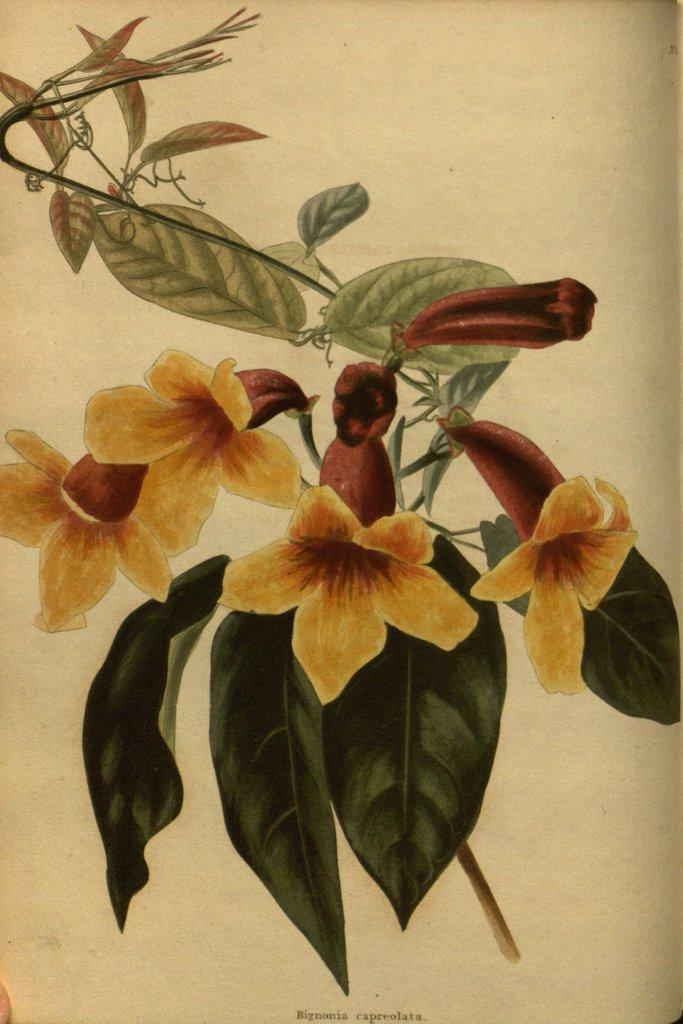What is the main subject of the painting in the image? The painting depicts a yellow flower. What are the main features of the flower in the painting? The flower has a stem and leaves. What type of education does the flower in the painting have? The flower in the painting is not a living being and therefore does not have an education. 